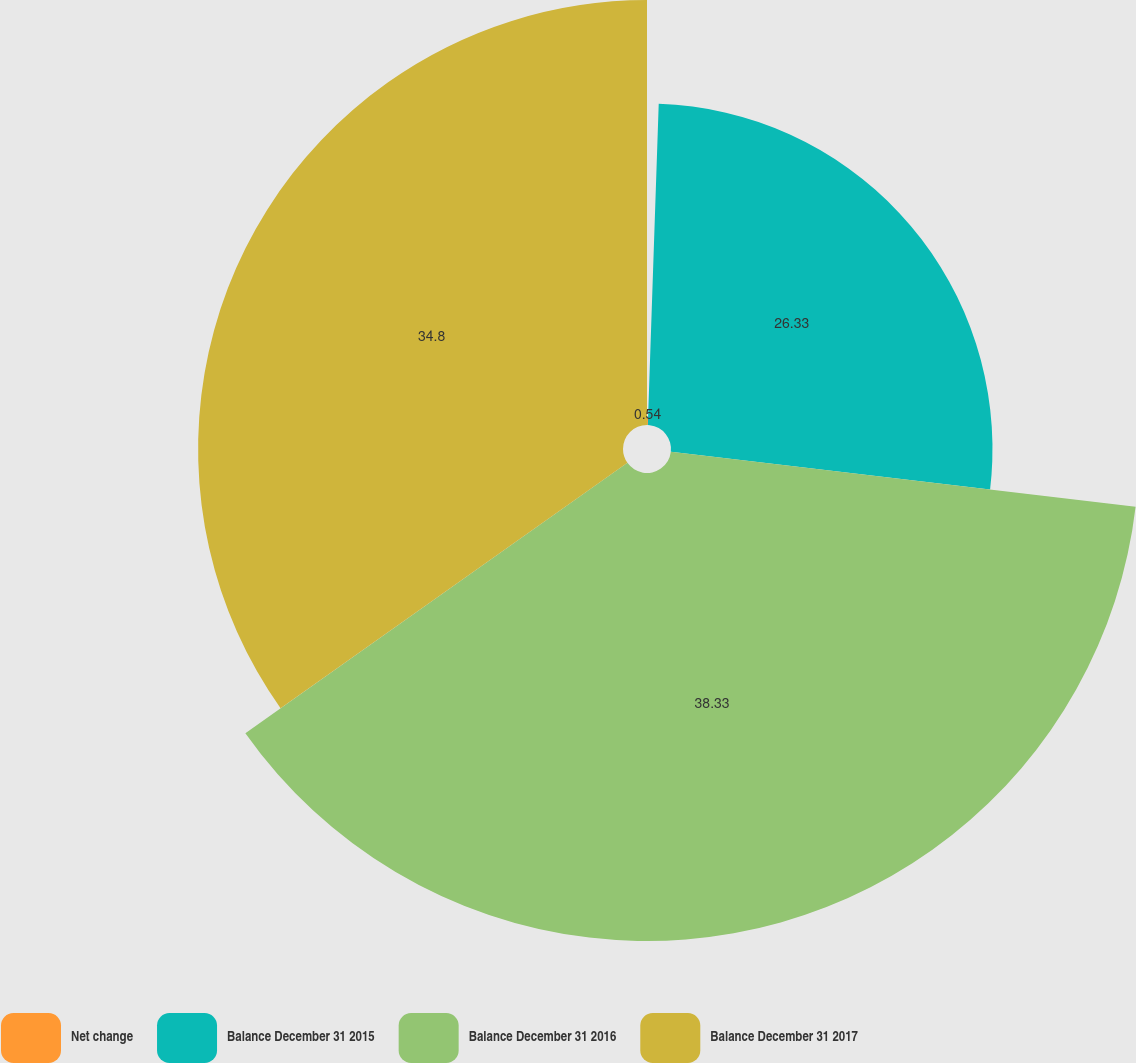<chart> <loc_0><loc_0><loc_500><loc_500><pie_chart><fcel>Net change<fcel>Balance December 31 2015<fcel>Balance December 31 2016<fcel>Balance December 31 2017<nl><fcel>0.54%<fcel>26.33%<fcel>38.33%<fcel>34.8%<nl></chart> 